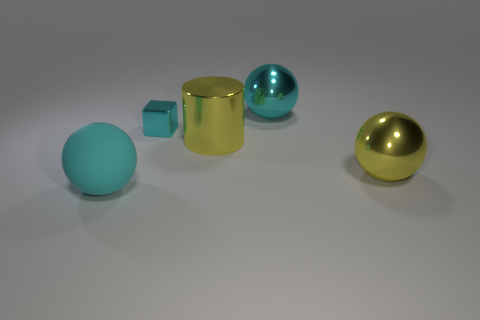How big is the cyan shiny thing in front of the cyan sphere to the right of the big matte thing?
Provide a short and direct response. Small. Is the color of the cube that is behind the large matte thing the same as the large metal ball that is in front of the large cyan shiny object?
Your answer should be very brief. No. The big ball that is in front of the cyan metallic block and to the right of the small cyan block is what color?
Give a very brief answer. Yellow. Are the cylinder and the yellow ball made of the same material?
Make the answer very short. Yes. What number of small objects are either gray matte spheres or cyan shiny blocks?
Your answer should be compact. 1. Is there any other thing that is the same shape as the cyan matte object?
Offer a terse response. Yes. Are there any other things that have the same size as the cyan block?
Give a very brief answer. No. There is a tiny block that is made of the same material as the yellow sphere; what is its color?
Give a very brief answer. Cyan. What is the color of the sphere behind the small cyan metallic block?
Offer a terse response. Cyan. What number of big metal objects are the same color as the cylinder?
Ensure brevity in your answer.  1. 